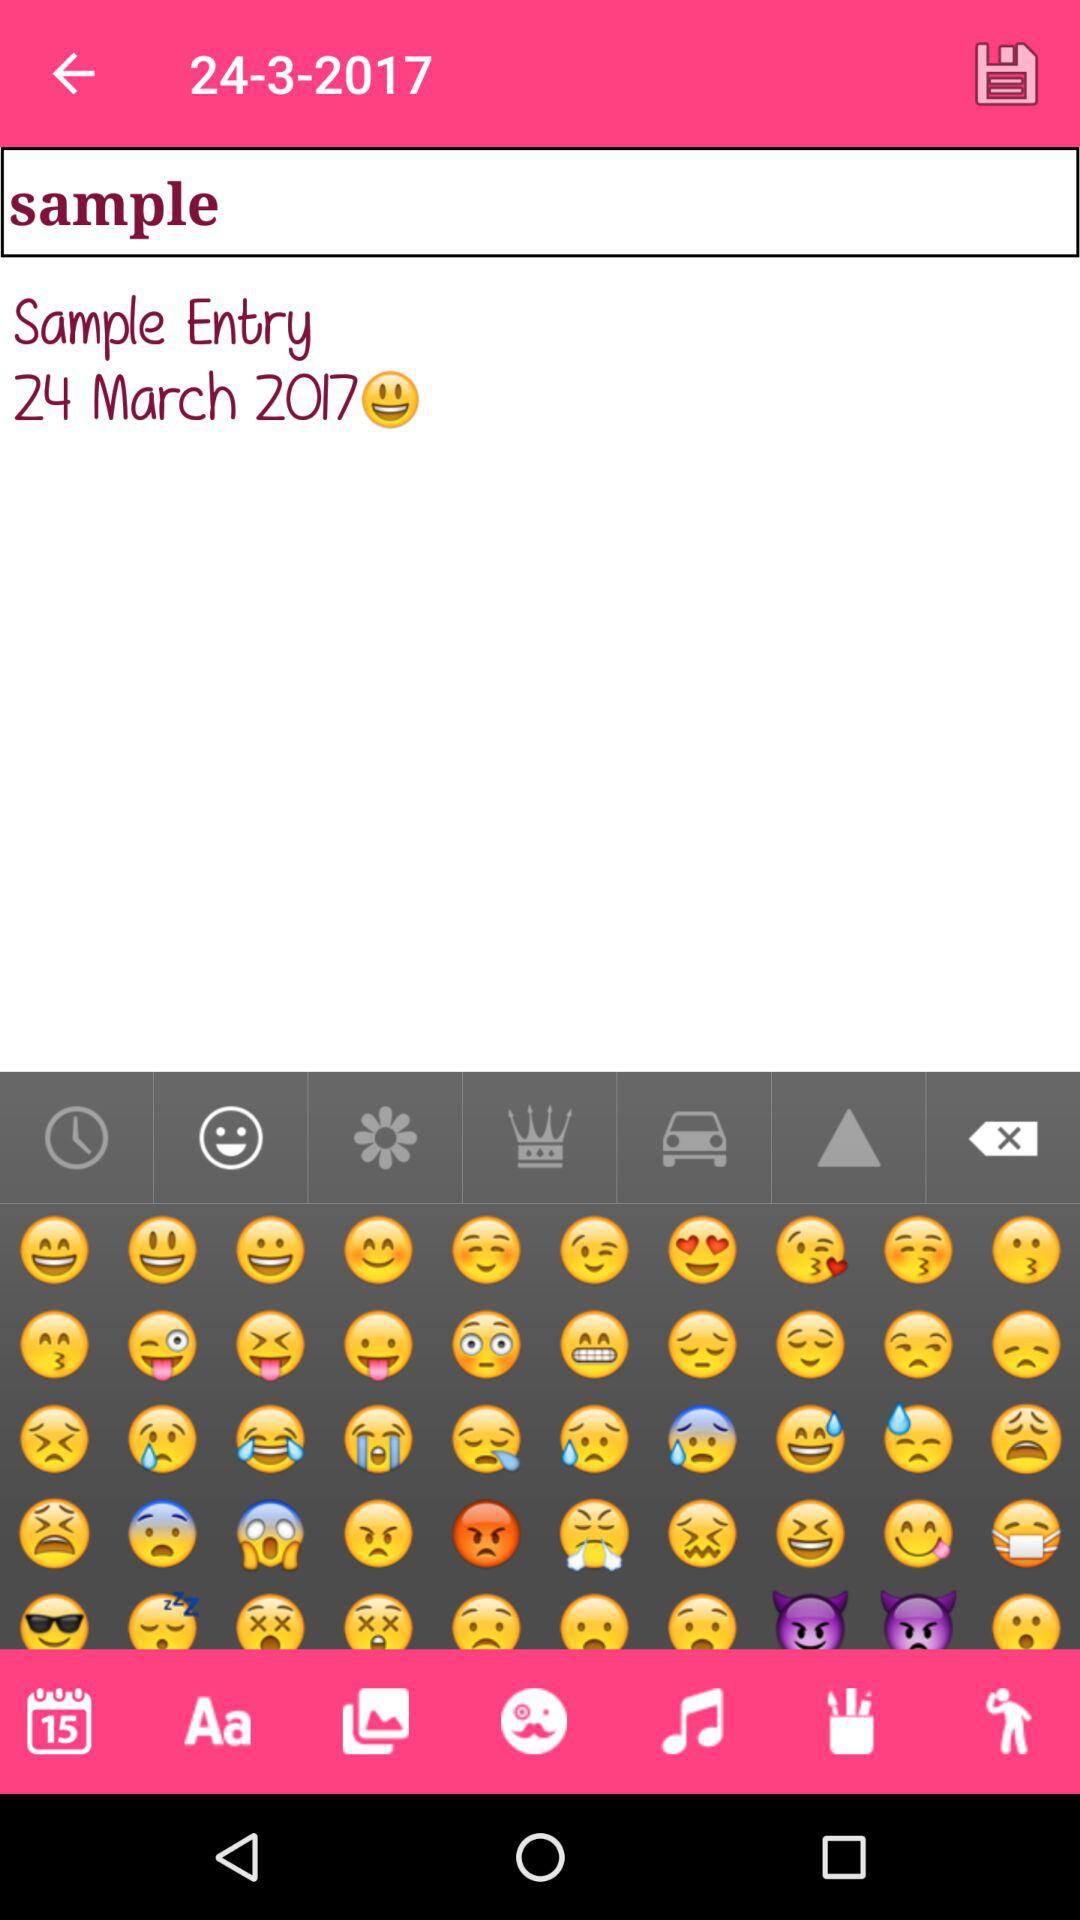Which samples have been saved?
When the provided information is insufficient, respond with <no answer>. <no answer> 